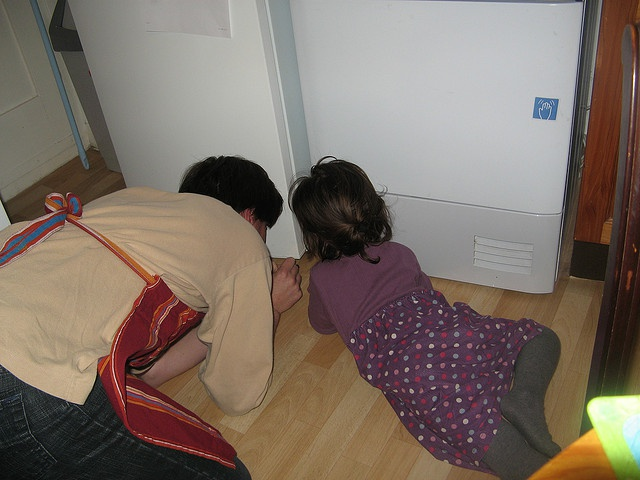Describe the objects in this image and their specific colors. I can see people in gray, tan, black, and maroon tones, refrigerator in gray, darkgray, and lightgray tones, people in gray, purple, and black tones, and refrigerator in gray, darkgray, and black tones in this image. 